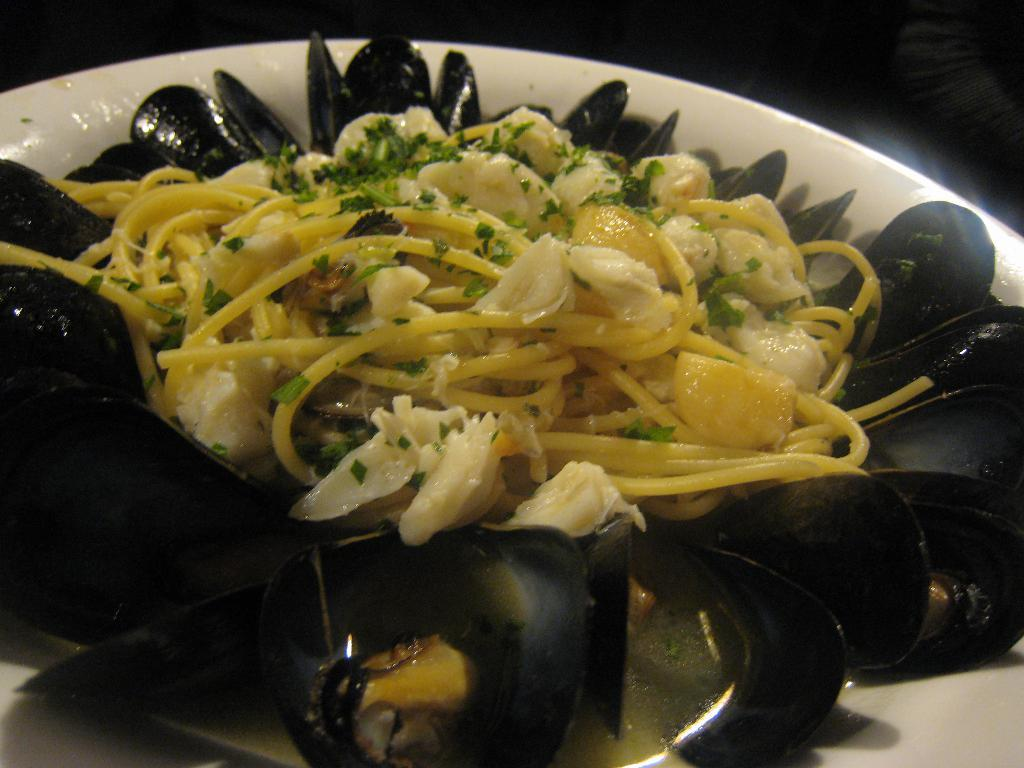What is the main subject in the foreground of the image? There is food in a bowl in the foreground of the image. Can you describe the food in the bowl? Unfortunately, the specific type of food cannot be determined from the provided facts. What type of apparatus is used to sort the food in the image? There is no apparatus present in the image, and the food is not being sorted. 